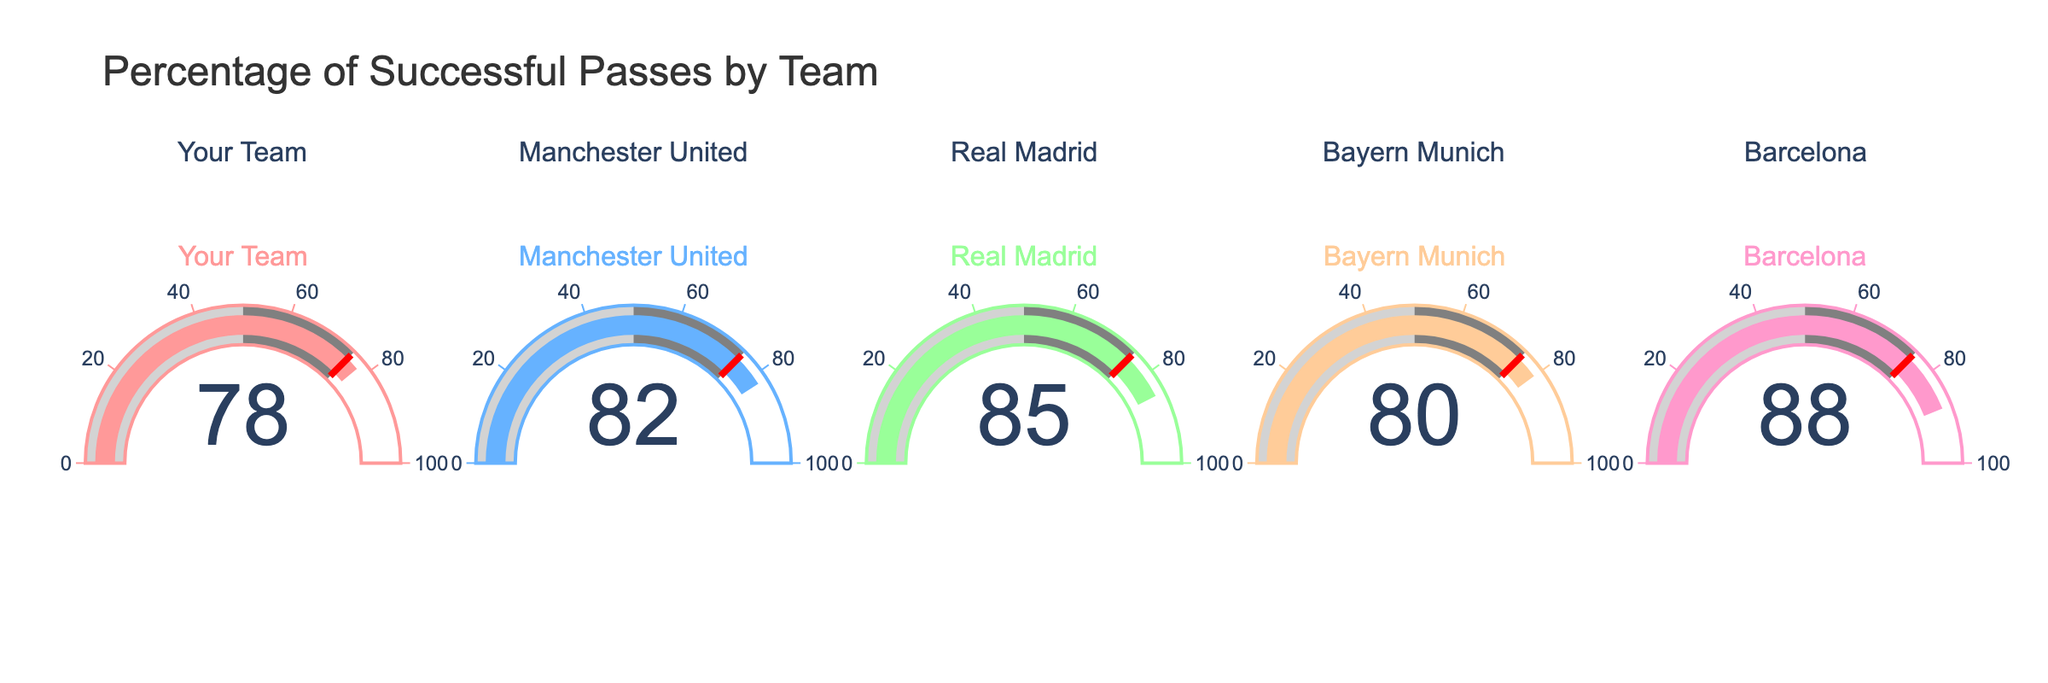What is the percentage of successful passes for Your Team? The figure shows a gauge with the value of 78 for Your Team.
Answer: 78 Which team has the highest percentage of successful passes? The gauge for Barcelona shows the highest value of 88 compared to the other teams.
Answer: Barcelona What's the difference in successful pass percentage between Your Team and Manchester United? Your Team has a percentage of 78 and Manchester United has 82. The difference is 82 - 78 which equals 4.
Answer: 4 How many teams have a successful pass percentage above 80? The teams with percentages above 80 are Manchester United, Real Madrid, and Barcelona. That's 3 teams in total.
Answer: 3 What is the range of the percentages displayed in the figure? The lowest percentage is 78 (Your Team) and the highest is 88 (Barcelona), so the range is 88 - 78 which equals 10.
Answer: 10 What's the average percentage of successful passes across all teams? Sum the percentages: 78 + 82 + 85 + 80 + 88 = 413. The average is 413/5 = 82.6.
Answer: 82.6 Which team has a percentage closest to the threshold line at 75? Your Team has a percentage of 78, which is the closest to the threshold line set at 75.
Answer: Your Team Is there any team with a percentage below 75? All the gauges show values above 75; the lowest is 78.
Answer: No 